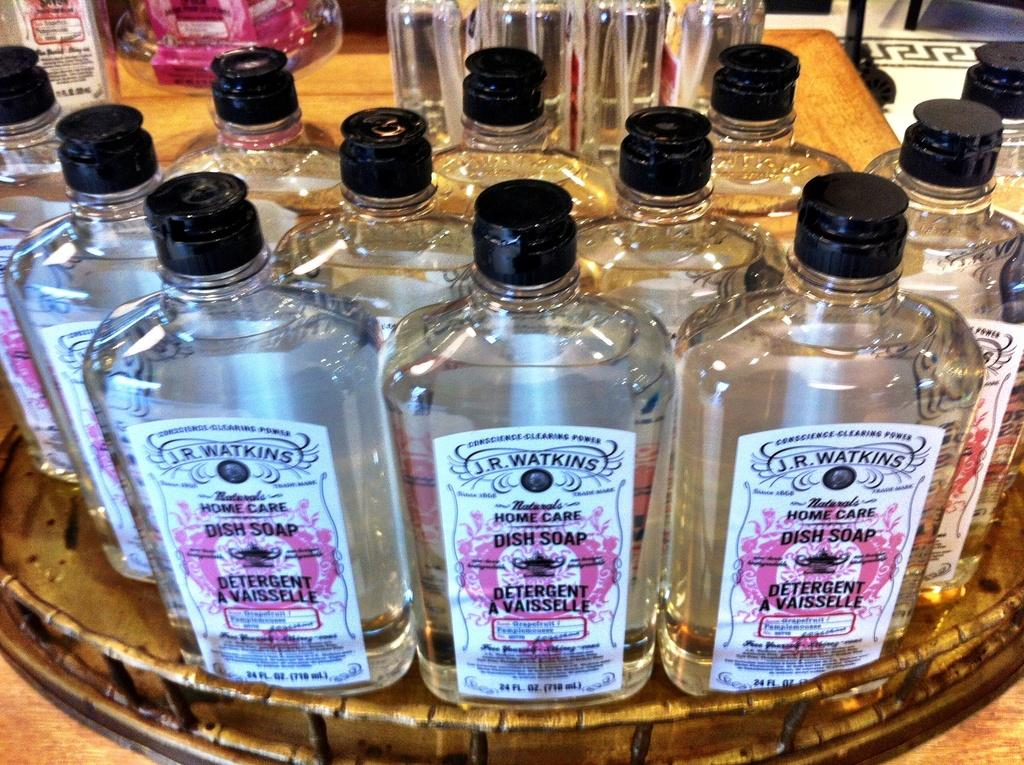<image>
Summarize the visual content of the image. Table top full of bottles of J.R. Watkins naturals home care. 